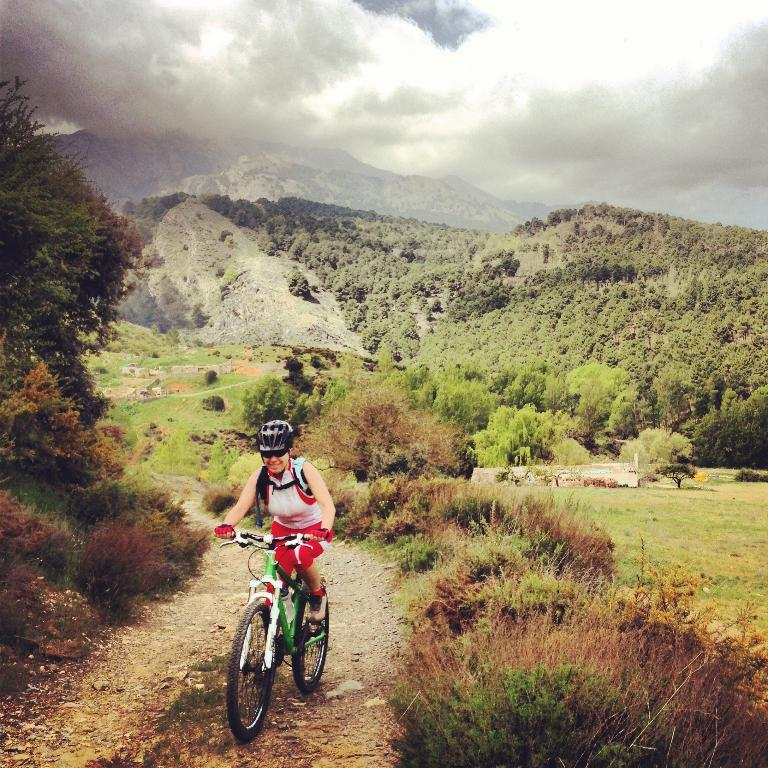Who is the main subject in the image? There is a woman in the image. What is the woman doing in the image? The woman is riding a bicycle. What safety gear is the woman wearing? The woman is wearing a helmet. What accessory is the woman wearing on her face? The woman is wearing sunglasses. What type of vegetation can be seen in the background of the image? There are plants and trees in the background of the image. What geographical feature is visible in the background of the image? There are hills in the background of the image. What is the weather like in the image? The sky is cloudy in the image. What caption is written on the bottom of the image? There is no caption written on the bottom of the image. Is the woman's brother playing with her in the image? There is no mention of a brother or any other person in the image, only the woman riding a bicycle. 